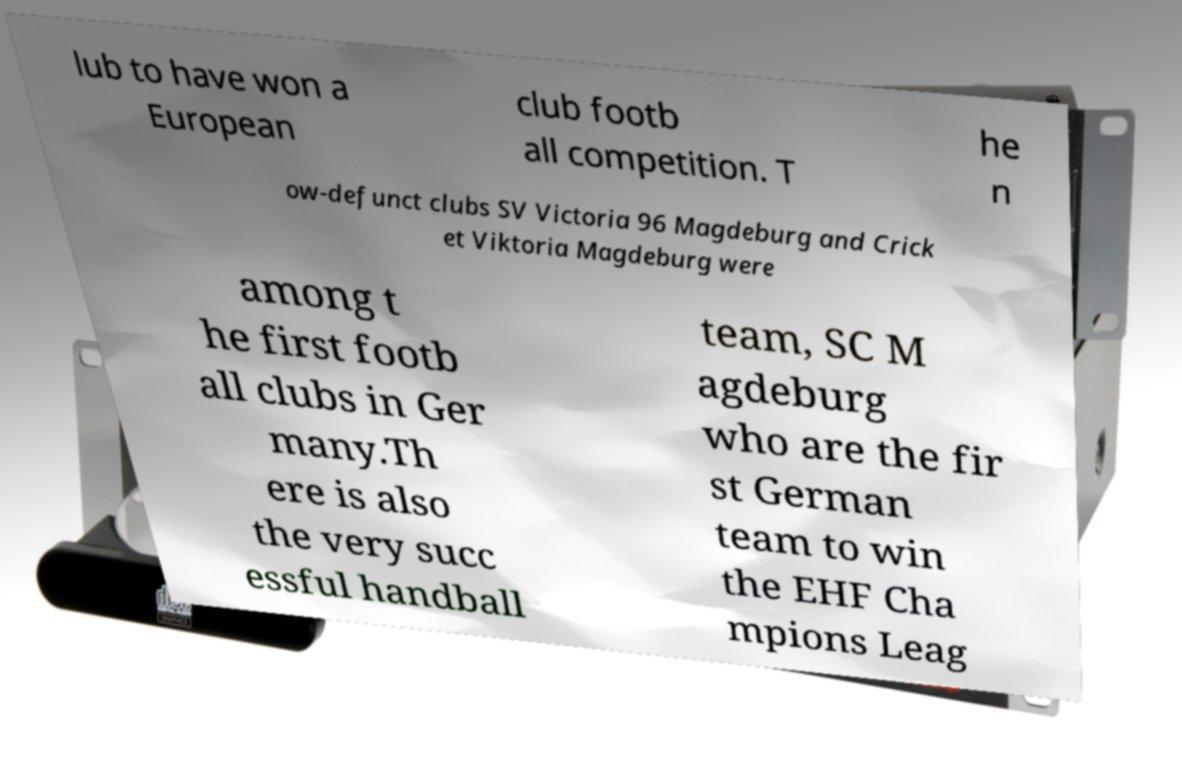What messages or text are displayed in this image? I need them in a readable, typed format. lub to have won a European club footb all competition. T he n ow-defunct clubs SV Victoria 96 Magdeburg and Crick et Viktoria Magdeburg were among t he first footb all clubs in Ger many.Th ere is also the very succ essful handball team, SC M agdeburg who are the fir st German team to win the EHF Cha mpions Leag 